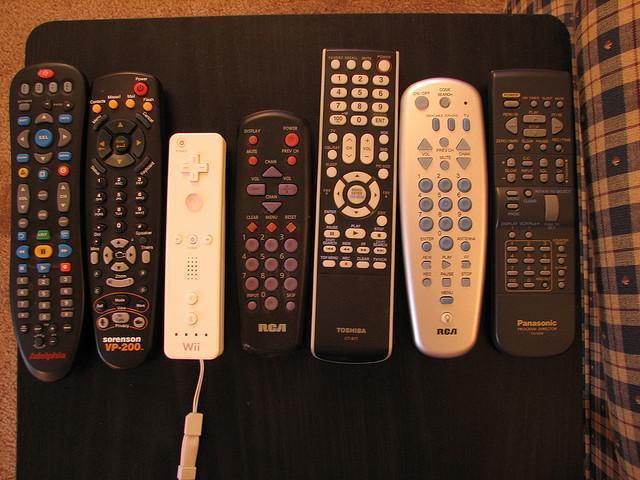How many gaming remotes are likely among the bunch?
Select the accurate answer and provide justification: `Answer: choice
Rationale: srationale.`
Options: Six, seven, one, two. Answer: one.
Rationale: There is a wii game controller among the remotes. 